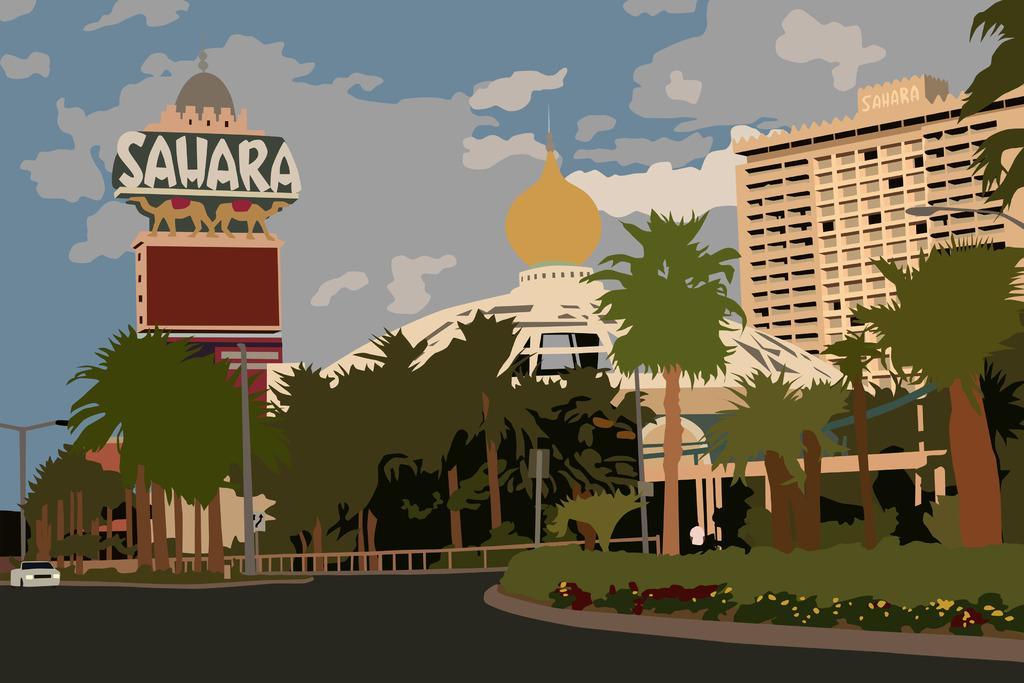Can you describe this image briefly? It is an editing picture. In the image in the center we can see the sky,clouds,buildings,trees,plants,poles,fences,road,car etc. 